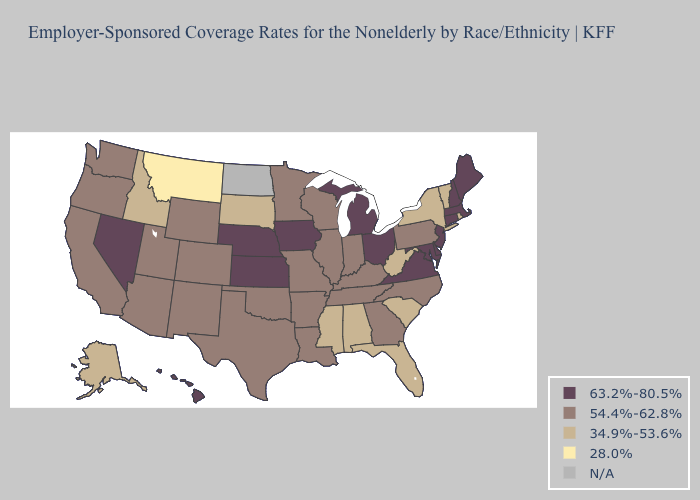Among the states that border Alabama , which have the lowest value?
Short answer required. Florida, Mississippi. Does Nevada have the highest value in the West?
Short answer required. Yes. Name the states that have a value in the range 34.9%-53.6%?
Write a very short answer. Alabama, Alaska, Florida, Idaho, Mississippi, New York, Rhode Island, South Carolina, South Dakota, Vermont, West Virginia. Name the states that have a value in the range 63.2%-80.5%?
Write a very short answer. Connecticut, Delaware, Hawaii, Iowa, Kansas, Maine, Maryland, Massachusetts, Michigan, Nebraska, Nevada, New Hampshire, New Jersey, Ohio, Virginia. What is the value of Washington?
Be succinct. 54.4%-62.8%. What is the value of New Mexico?
Write a very short answer. 54.4%-62.8%. Which states hav the highest value in the West?
Short answer required. Hawaii, Nevada. Name the states that have a value in the range 63.2%-80.5%?
Answer briefly. Connecticut, Delaware, Hawaii, Iowa, Kansas, Maine, Maryland, Massachusetts, Michigan, Nebraska, Nevada, New Hampshire, New Jersey, Ohio, Virginia. What is the value of Michigan?
Write a very short answer. 63.2%-80.5%. What is the lowest value in the USA?
Give a very brief answer. 28.0%. Name the states that have a value in the range 54.4%-62.8%?
Write a very short answer. Arizona, Arkansas, California, Colorado, Georgia, Illinois, Indiana, Kentucky, Louisiana, Minnesota, Missouri, New Mexico, North Carolina, Oklahoma, Oregon, Pennsylvania, Tennessee, Texas, Utah, Washington, Wisconsin, Wyoming. Which states have the lowest value in the USA?
Write a very short answer. Montana. Name the states that have a value in the range 54.4%-62.8%?
Keep it brief. Arizona, Arkansas, California, Colorado, Georgia, Illinois, Indiana, Kentucky, Louisiana, Minnesota, Missouri, New Mexico, North Carolina, Oklahoma, Oregon, Pennsylvania, Tennessee, Texas, Utah, Washington, Wisconsin, Wyoming. Name the states that have a value in the range 54.4%-62.8%?
Be succinct. Arizona, Arkansas, California, Colorado, Georgia, Illinois, Indiana, Kentucky, Louisiana, Minnesota, Missouri, New Mexico, North Carolina, Oklahoma, Oregon, Pennsylvania, Tennessee, Texas, Utah, Washington, Wisconsin, Wyoming. 